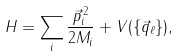Convert formula to latex. <formula><loc_0><loc_0><loc_500><loc_500>H = \sum _ { i } \frac { \vec { p } _ { i } ^ { \, 2 } } { 2 M _ { i } } + V ( \{ \vec { q } _ { \ell } \} ) ,</formula> 